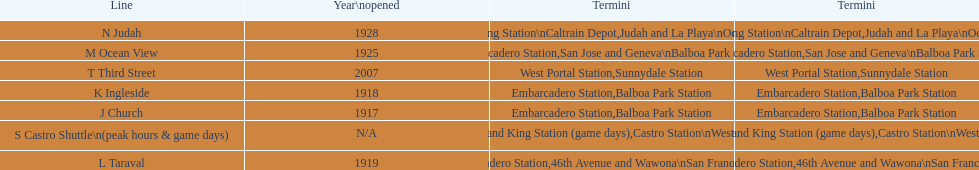Can you give me this table as a dict? {'header': ['Line', 'Year\\nopened', 'Termini', 'Termini'], 'rows': [['N Judah', '1928', '4th and King Station\\nCaltrain Depot', 'Judah and La Playa\\nOcean Beach'], ['M Ocean View', '1925', 'Embarcadero Station', 'San Jose and Geneva\\nBalboa Park Station'], ['T Third Street', '2007', 'West Portal Station', 'Sunnydale Station'], ['K Ingleside', '1918', 'Embarcadero Station', 'Balboa Park Station'], ['J Church', '1917', 'Embarcadero Station', 'Balboa Park Station'], ['S Castro Shuttle\\n(peak hours & game days)', 'N/A', 'Embarcadero Station\\n4th and King Station\xa0(game days)', 'Castro Station\\nWest Portal Station\xa0(game days)'], ['L Taraval', '1919', 'Embarcadero Station', '46th Avenue and Wawona\\nSan Francisco Zoo']]} On game days, which line do you want to use? S Castro Shuttle. 